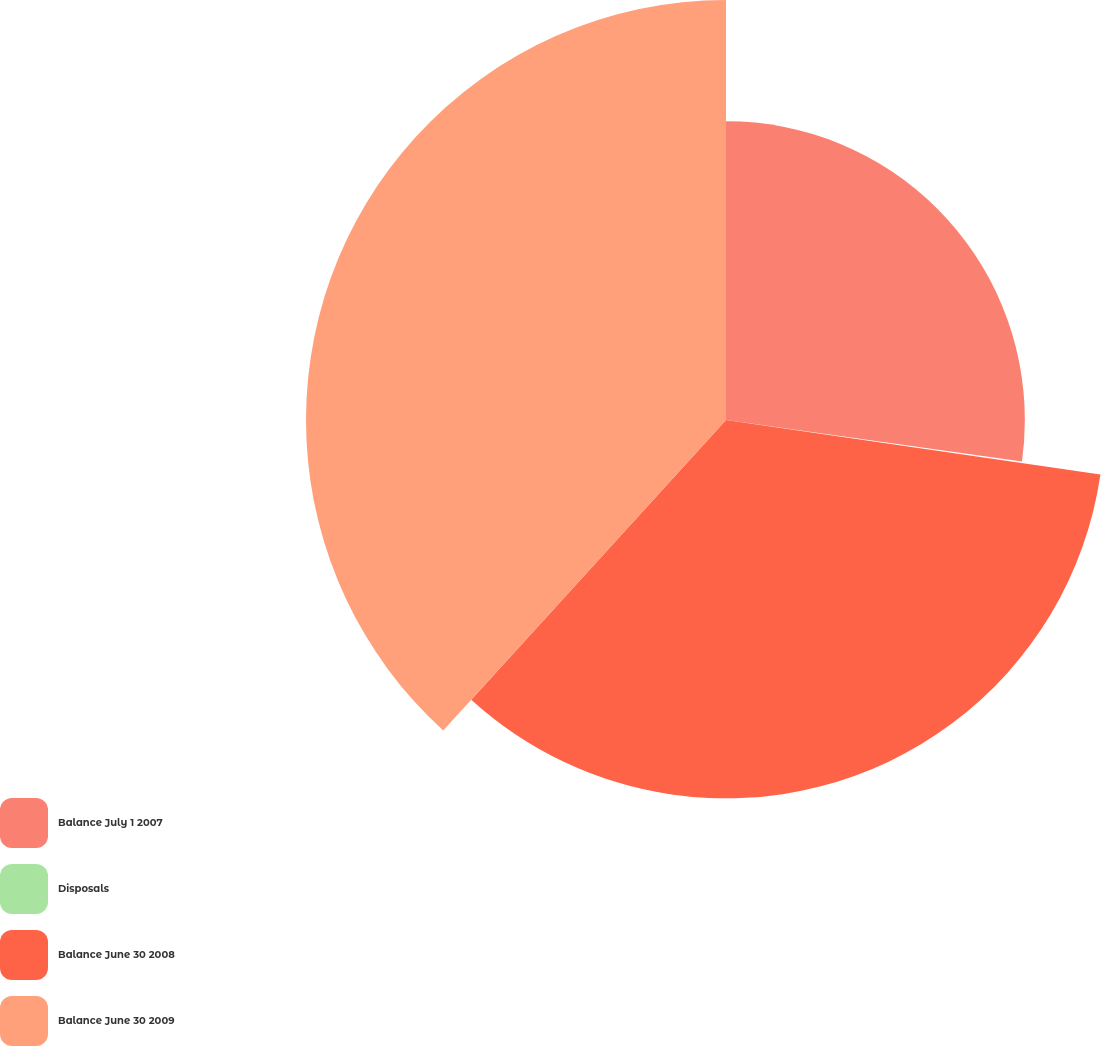<chart> <loc_0><loc_0><loc_500><loc_500><pie_chart><fcel>Balance July 1 2007<fcel>Disposals<fcel>Balance June 30 2008<fcel>Balance June 30 2009<nl><fcel>27.21%<fcel>0.09%<fcel>34.45%<fcel>38.24%<nl></chart> 